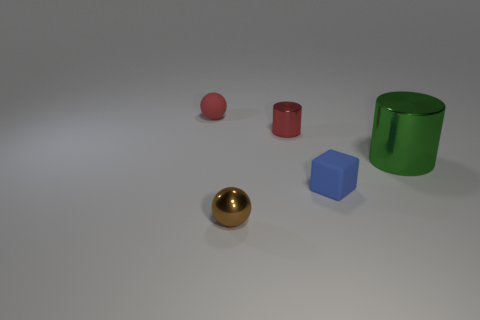Do the small cylinder and the tiny matte ball have the same color?
Keep it short and to the point. Yes. Is there any other thing of the same color as the big object?
Your answer should be very brief. No. What number of other objects are there of the same material as the red ball?
Your answer should be very brief. 1. What number of gray things are cylinders or tiny metal things?
Keep it short and to the point. 0. Is the shape of the tiny red object on the right side of the rubber sphere the same as the metal thing right of the red metal cylinder?
Make the answer very short. Yes. Does the tiny cylinder have the same color as the tiny sphere that is behind the green cylinder?
Provide a succinct answer. Yes. Is the color of the small rubber thing on the left side of the tiny red cylinder the same as the tiny cylinder?
Offer a terse response. Yes. What number of things are big gray rubber cubes or small shiny things behind the green metal object?
Provide a succinct answer. 1. What is the tiny object that is both in front of the tiny red shiny thing and to the right of the metal ball made of?
Keep it short and to the point. Rubber. What is the sphere that is in front of the tiny red matte object made of?
Ensure brevity in your answer.  Metal. 